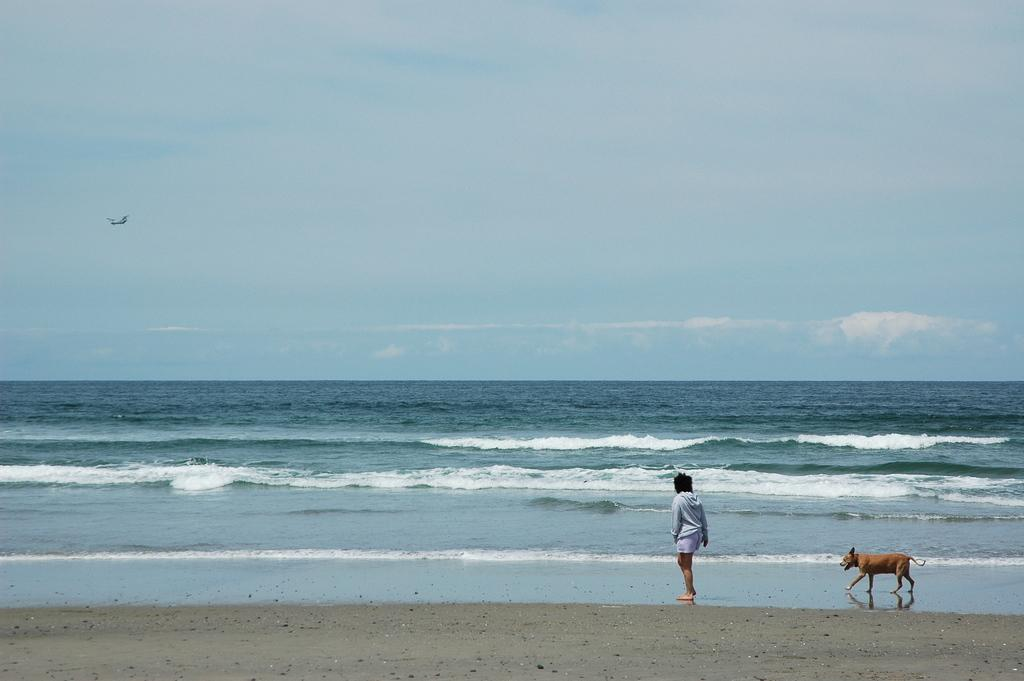What is the main subject of the image? There is a person standing on the beach in the image. Is there any other living creature present in the image? Yes, there is a dog behind the person in the image. What can be seen in the background of the image? There is a river and the sky visible in the background of the image. What type of van is parked near the river in the image? There is no van present in the image; it features a person standing on the beach and a dog behind them. What kind of system is responsible for the weather conditions in the image? There is no specific system mentioned in the image; it simply shows a person, a dog, a beach, a river, and the sky. 